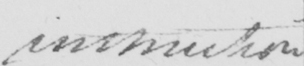Please provide the text content of this handwritten line. instruction 